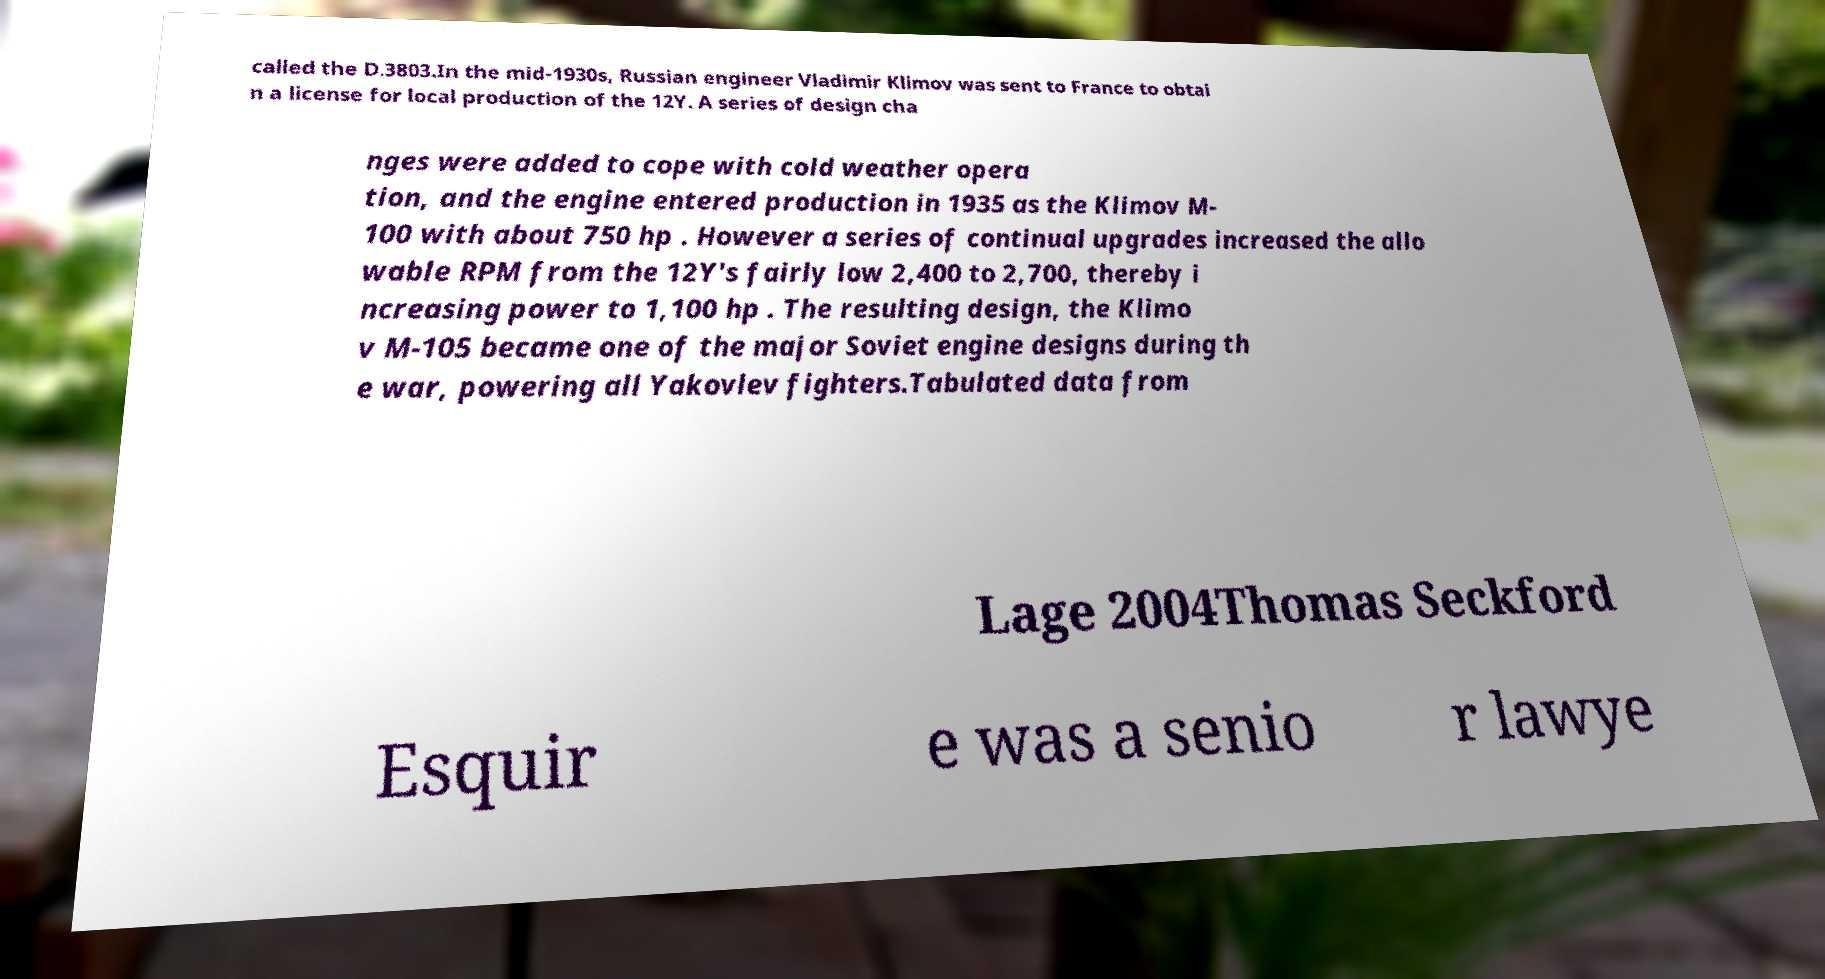Please read and relay the text visible in this image. What does it say? called the D.3803.In the mid-1930s, Russian engineer Vladimir Klimov was sent to France to obtai n a license for local production of the 12Y. A series of design cha nges were added to cope with cold weather opera tion, and the engine entered production in 1935 as the Klimov M- 100 with about 750 hp . However a series of continual upgrades increased the allo wable RPM from the 12Y's fairly low 2,400 to 2,700, thereby i ncreasing power to 1,100 hp . The resulting design, the Klimo v M-105 became one of the major Soviet engine designs during th e war, powering all Yakovlev fighters.Tabulated data from Lage 2004Thomas Seckford Esquir e was a senio r lawye 